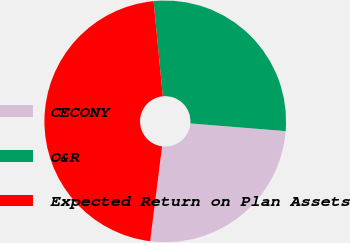Convert chart to OTSL. <chart><loc_0><loc_0><loc_500><loc_500><pie_chart><fcel>CECONY<fcel>O&R<fcel>Expected Return on Plan Assets<nl><fcel>25.71%<fcel>27.82%<fcel>46.47%<nl></chart> 